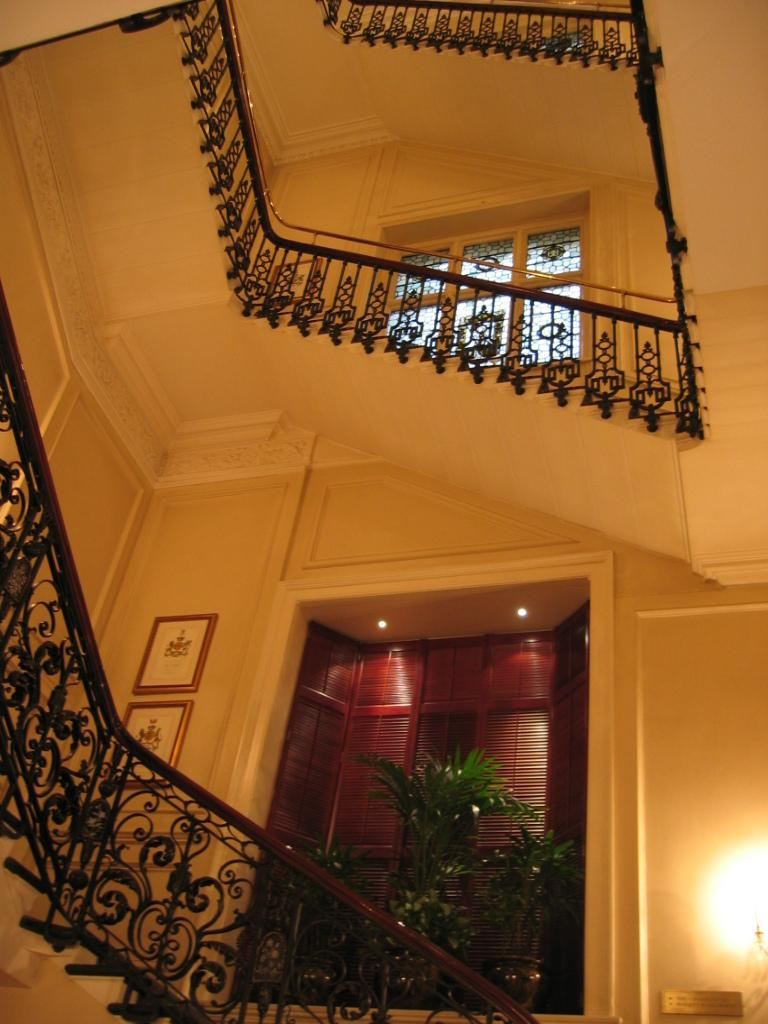What type of structure can be seen in the image? There are railings and windows visible in the image, which suggests a building or room. What decorative elements are present in the image contain? There are flower pots with plants and a lamp at the bottom right side of the image. Are there any wall-mounted items in the image? Yes, there are two photo frames attached to the wall in the image. What type of coal is being used to fuel the lamp in the image? There is no coal present in the image, and the lamp is not fueled by coal. Can you see a whip being used to discipline a pet in the image? There is no whip or pet present in the image, so this activity cannot be observed. 